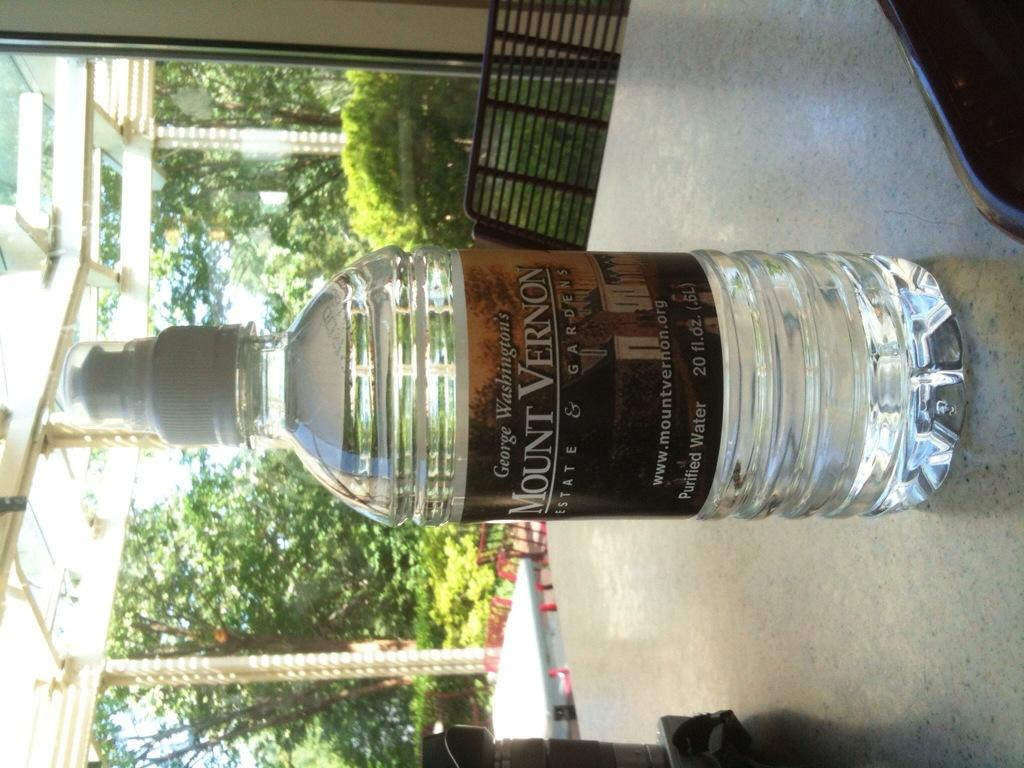What type of vegetation can be seen in the image? There are trees in the image. What type of furniture is present in the image? There is a chair and a table in the image. What object is placed on the table? There is a bottle on the table. How many patches of grass are visible in the image? There is no grass visible in the image, only trees. What type of eggs are being used to make the omelet in the image? There is no omelet or eggs present in the image. 